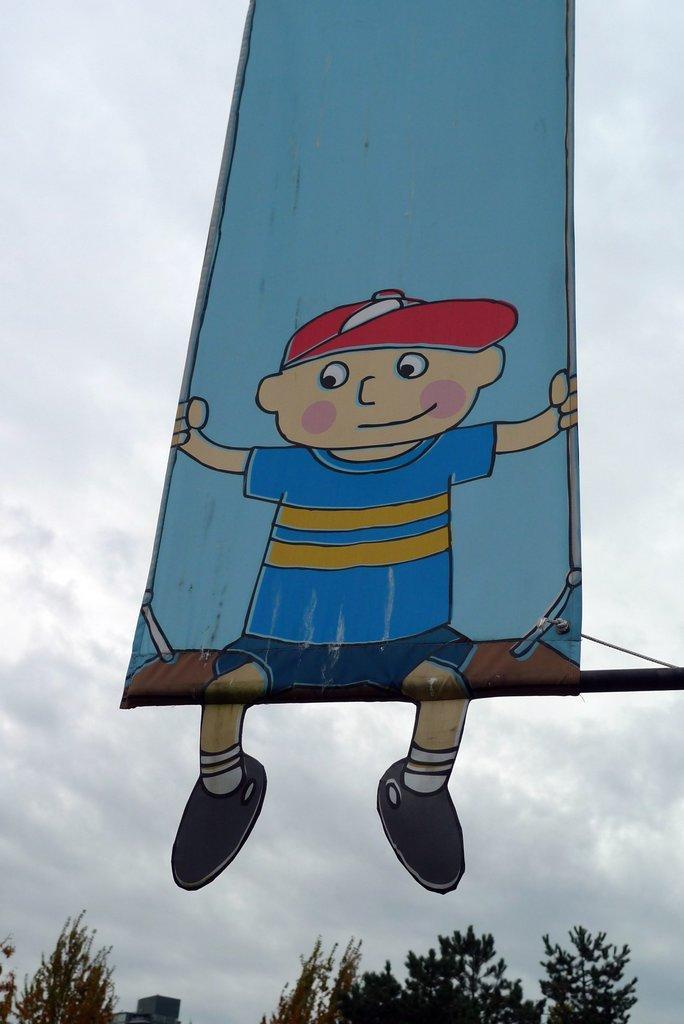Describe this image in one or two sentences. In this image in the front there is a banner. In the background there are trees, there is a building and the sky is cloudy. 